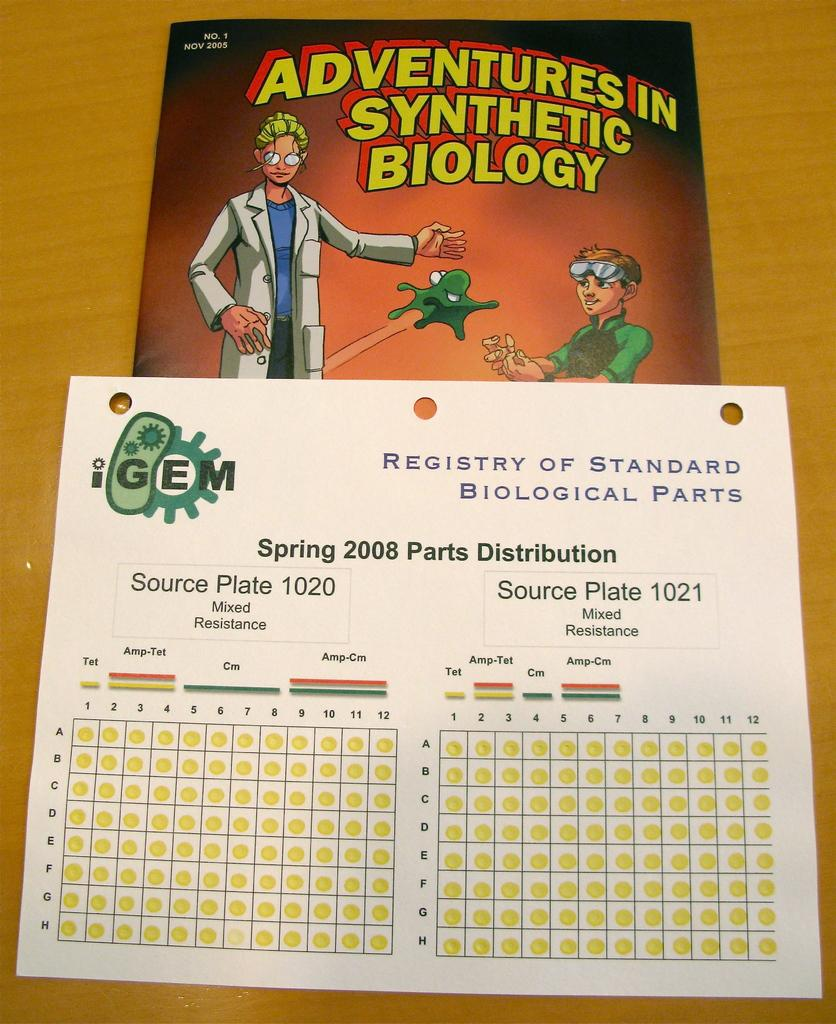<image>
Relay a brief, clear account of the picture shown. A book entitled Adventures in Synthetic Biology and a registry below. 